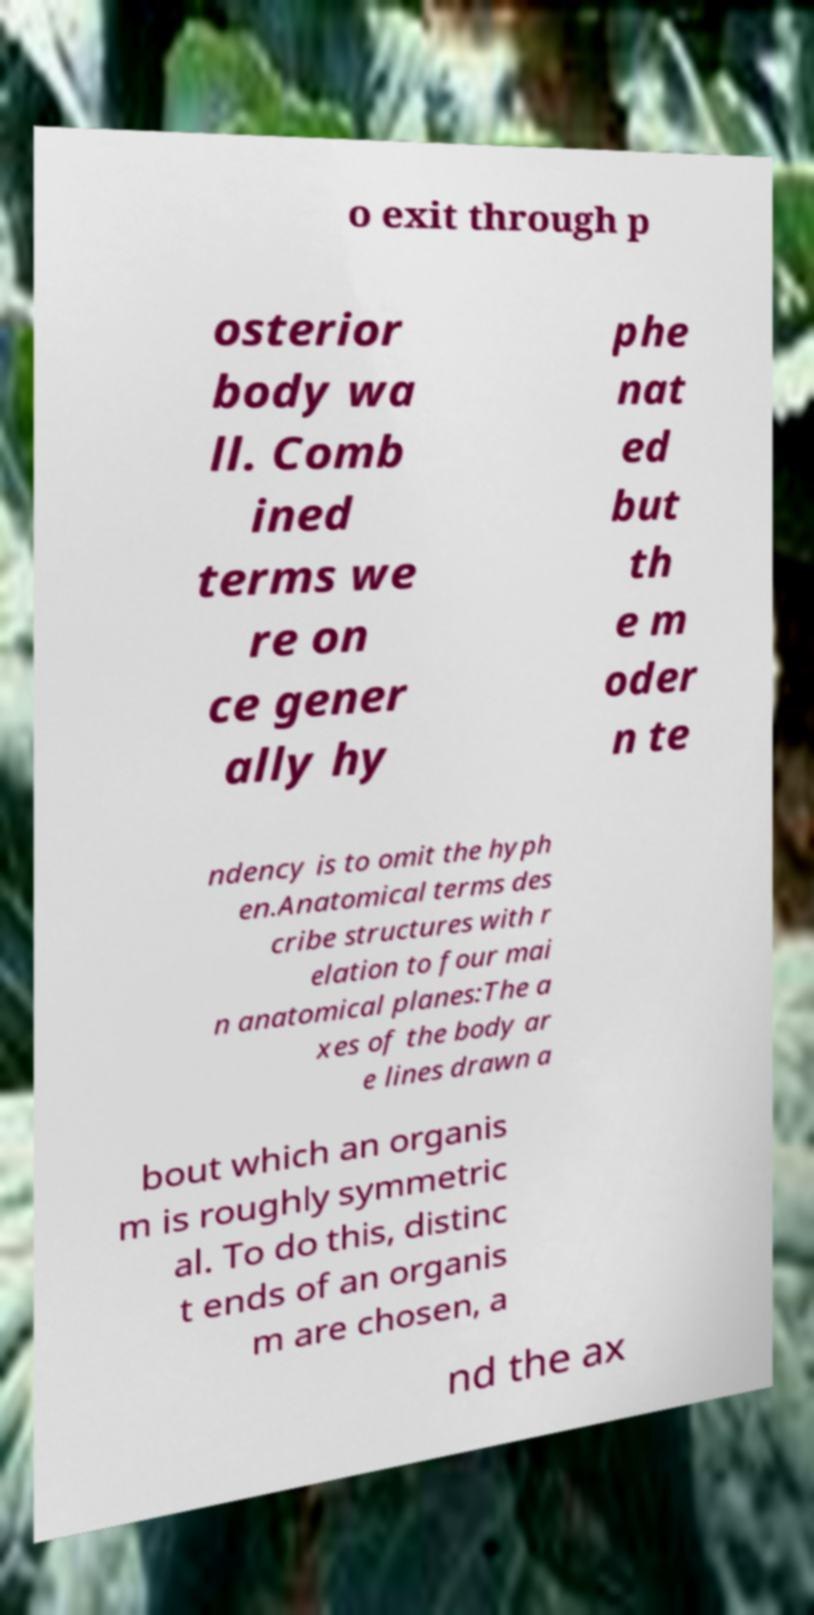Please identify and transcribe the text found in this image. o exit through p osterior body wa ll. Comb ined terms we re on ce gener ally hy phe nat ed but th e m oder n te ndency is to omit the hyph en.Anatomical terms des cribe structures with r elation to four mai n anatomical planes:The a xes of the body ar e lines drawn a bout which an organis m is roughly symmetric al. To do this, distinc t ends of an organis m are chosen, a nd the ax 